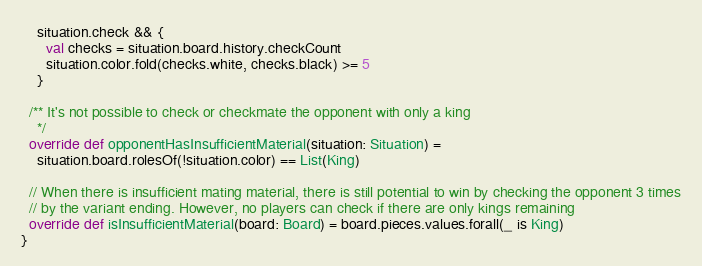Convert code to text. <code><loc_0><loc_0><loc_500><loc_500><_Scala_>    situation.check && {
      val checks = situation.board.history.checkCount
      situation.color.fold(checks.white, checks.black) >= 5
    }

  /** It's not possible to check or checkmate the opponent with only a king
    */
  override def opponentHasInsufficientMaterial(situation: Situation) =
    situation.board.rolesOf(!situation.color) == List(King)

  // When there is insufficient mating material, there is still potential to win by checking the opponent 3 times
  // by the variant ending. However, no players can check if there are only kings remaining
  override def isInsufficientMaterial(board: Board) = board.pieces.values.forall(_ is King)
}</code> 